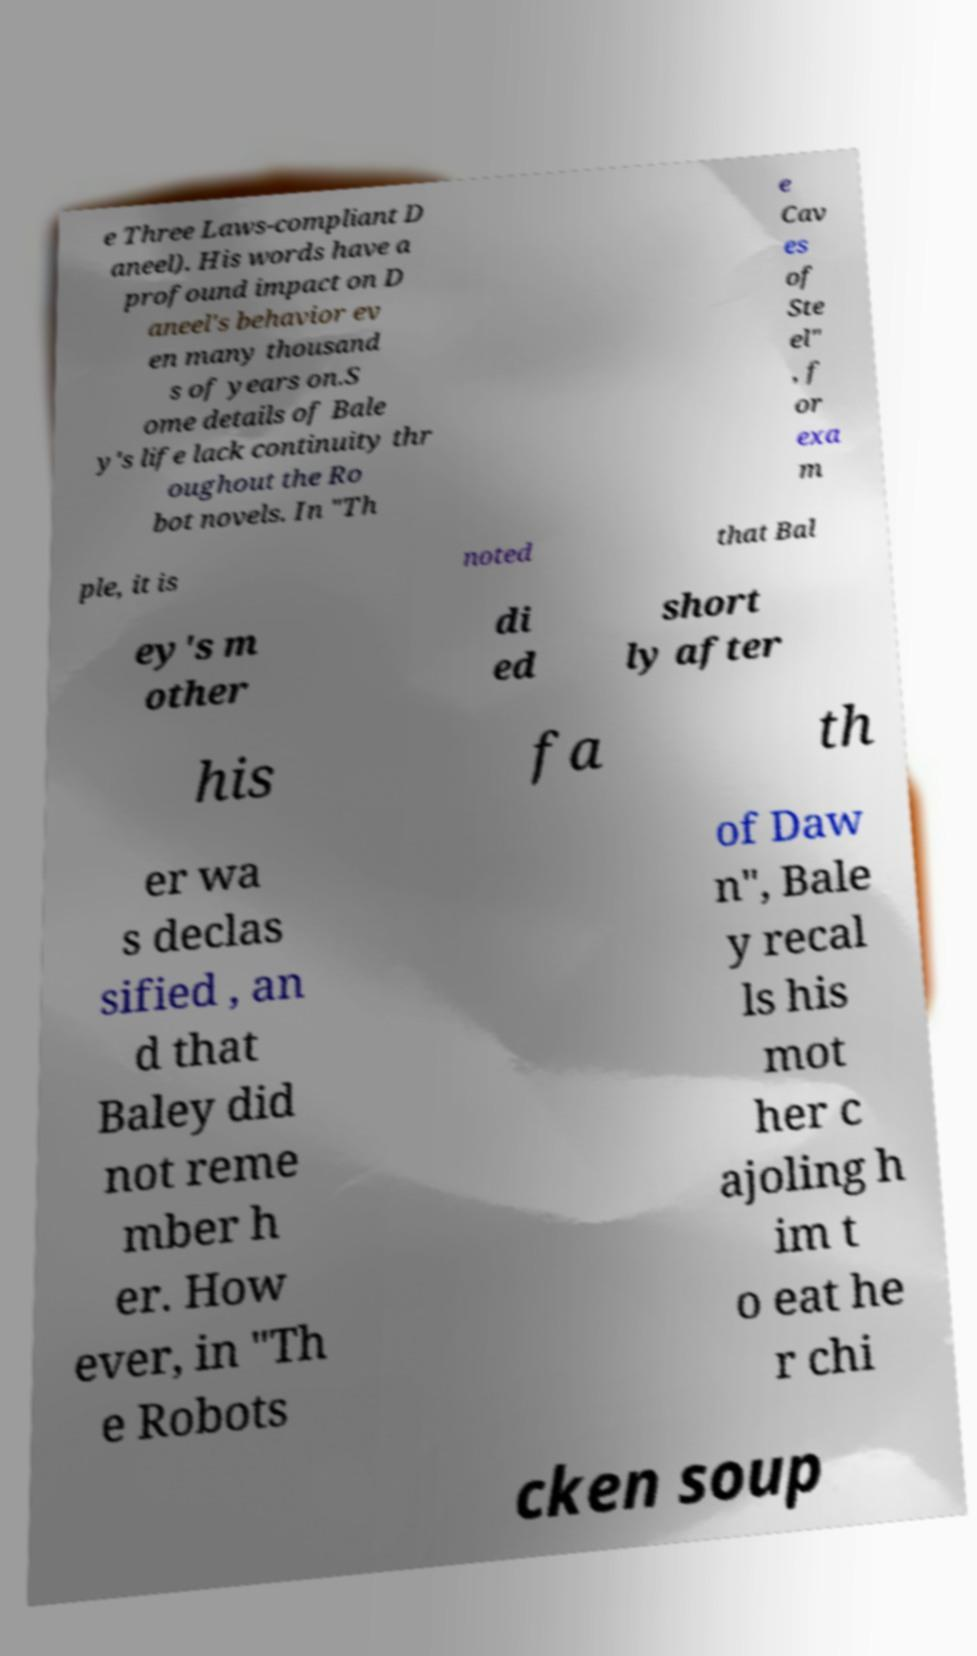What messages or text are displayed in this image? I need them in a readable, typed format. e Three Laws-compliant D aneel). His words have a profound impact on D aneel's behavior ev en many thousand s of years on.S ome details of Bale y's life lack continuity thr oughout the Ro bot novels. In "Th e Cav es of Ste el" , f or exa m ple, it is noted that Bal ey's m other di ed short ly after his fa th er wa s declas sified , an d that Baley did not reme mber h er. How ever, in "Th e Robots of Daw n", Bale y recal ls his mot her c ajoling h im t o eat he r chi cken soup 